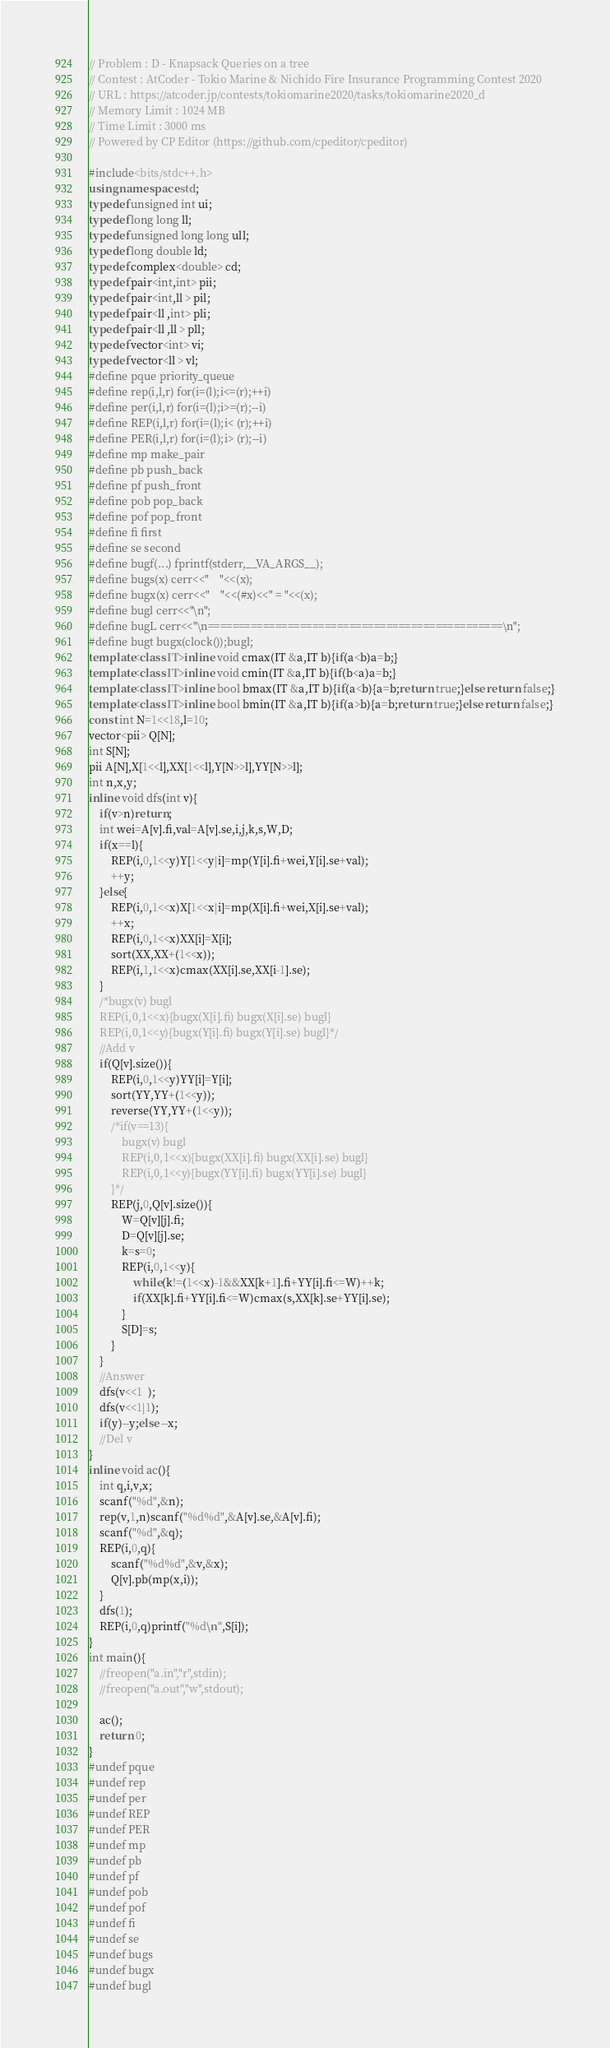<code> <loc_0><loc_0><loc_500><loc_500><_C++_>
// Problem : D - Knapsack Queries on a tree
// Contest : AtCoder - Tokio Marine & Nichido Fire Insurance Programming Contest 2020
// URL : https://atcoder.jp/contests/tokiomarine2020/tasks/tokiomarine2020_d
// Memory Limit : 1024 MB
// Time Limit : 3000 ms
// Powered by CP Editor (https://github.com/cpeditor/cpeditor)

#include<bits/stdc++.h>
using namespace std;
typedef unsigned int ui;
typedef long long ll;
typedef unsigned long long ull;
typedef long double ld;
typedef complex<double> cd;
typedef pair<int,int> pii;
typedef pair<int,ll > pil;
typedef pair<ll ,int> pli;
typedef pair<ll ,ll > pll;
typedef vector<int> vi;
typedef vector<ll > vl;
#define pque priority_queue
#define rep(i,l,r) for(i=(l);i<=(r);++i)
#define per(i,l,r) for(i=(l);i>=(r);--i)
#define REP(i,l,r) for(i=(l);i< (r);++i)
#define PER(i,l,r) for(i=(l);i> (r);--i)
#define mp make_pair
#define pb push_back
#define pf push_front
#define pob pop_back
#define pof pop_front
#define fi first
#define se second
#define bugf(...) fprintf(stderr,__VA_ARGS__);
#define bugs(x) cerr<<"    "<<(x);
#define bugx(x) cerr<<"    "<<(#x)<<" = "<<(x);
#define bugl cerr<<"\n";
#define bugL cerr<<"\n================================================\n";
#define bugt bugx(clock());bugl;
template<class IT>inline void cmax(IT &a,IT b){if(a<b)a=b;}
template<class IT>inline void cmin(IT &a,IT b){if(b<a)a=b;}
template<class IT>inline bool bmax(IT &a,IT b){if(a<b){a=b;return true;}else return false;}
template<class IT>inline bool bmin(IT &a,IT b){if(a>b){a=b;return true;}else return false;}
const int N=1<<18,l=10;
vector<pii> Q[N];
int S[N];
pii A[N],X[1<<l],XX[1<<l],Y[N>>l],YY[N>>l];
int n,x,y;
inline void dfs(int v){
	if(v>n)return;
	int wei=A[v].fi,val=A[v].se,i,j,k,s,W,D;
	if(x==l){
		REP(i,0,1<<y)Y[1<<y|i]=mp(Y[i].fi+wei,Y[i].se+val);
		++y;
	}else{
		REP(i,0,1<<x)X[1<<x|i]=mp(X[i].fi+wei,X[i].se+val);
		++x;
		REP(i,0,1<<x)XX[i]=X[i];
		sort(XX,XX+(1<<x));
		REP(i,1,1<<x)cmax(XX[i].se,XX[i-1].se);
	}
	/*bugx(v) bugl
	REP(i,0,1<<x){bugx(X[i].fi) bugx(X[i].se) bugl}
	REP(i,0,1<<y){bugx(Y[i].fi) bugx(Y[i].se) bugl}*/
	//Add v
	if(Q[v].size()){
		REP(i,0,1<<y)YY[i]=Y[i];
		sort(YY,YY+(1<<y));
		reverse(YY,YY+(1<<y));
		/*if(v==13){
			bugx(v) bugl
			REP(i,0,1<<x){bugx(XX[i].fi) bugx(XX[i].se) bugl}
			REP(i,0,1<<y){bugx(YY[i].fi) bugx(YY[i].se) bugl}
		}*/
		REP(j,0,Q[v].size()){
			W=Q[v][j].fi;
			D=Q[v][j].se;
			k=s=0;
			REP(i,0,1<<y){
				while(k!=(1<<x)-1&&XX[k+1].fi+YY[i].fi<=W)++k;
				if(XX[k].fi+YY[i].fi<=W)cmax(s,XX[k].se+YY[i].se);
			}
			S[D]=s;
		}
	}
	//Answer
	dfs(v<<1  );
	dfs(v<<1|1);
	if(y)--y;else --x;
	//Del v
}
inline void ac(){
	int q,i,v,x;
	scanf("%d",&n);
	rep(v,1,n)scanf("%d%d",&A[v].se,&A[v].fi);
	scanf("%d",&q);
	REP(i,0,q){
		scanf("%d%d",&v,&x);
		Q[v].pb(mp(x,i));
	}
	dfs(1);
	REP(i,0,q)printf("%d\n",S[i]);
}
int main(){
	//freopen("a.in","r",stdin);
	//freopen("a.out","w",stdout);
	
	ac();
	return 0;
}
#undef pque
#undef rep
#undef per
#undef REP
#undef PER
#undef mp
#undef pb
#undef pf
#undef pob
#undef pof
#undef fi
#undef se
#undef bugs
#undef bugx
#undef bugl</code> 